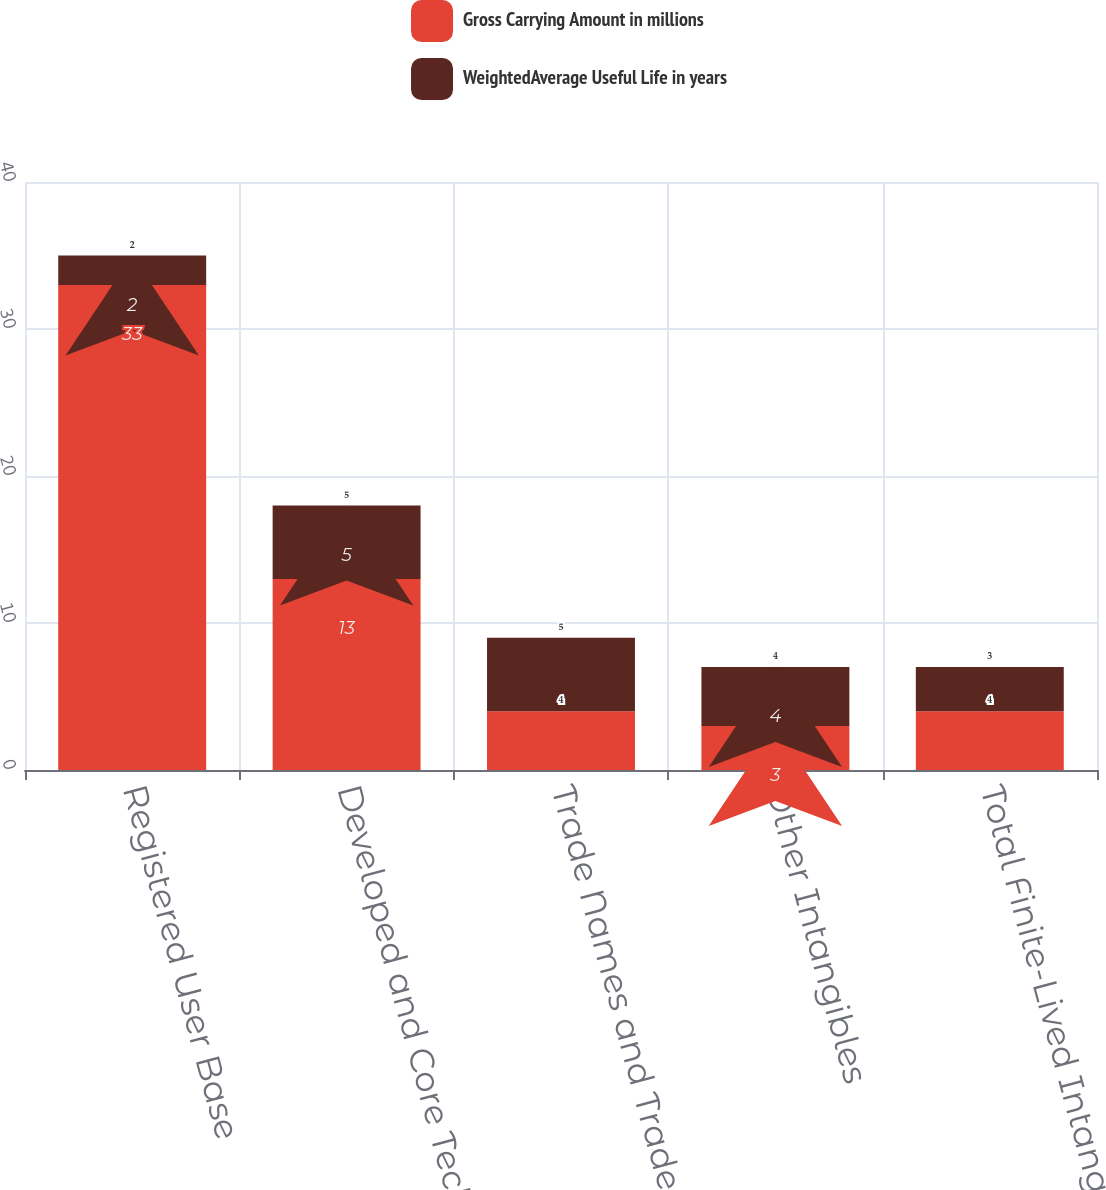Convert chart. <chart><loc_0><loc_0><loc_500><loc_500><stacked_bar_chart><ecel><fcel>Registered User Base<fcel>Developed and Core Technology<fcel>Trade Names and Trademarks<fcel>Other Intangibles<fcel>Total Finite-Lived Intangibles<nl><fcel>Gross Carrying Amount in millions<fcel>33<fcel>13<fcel>4<fcel>3<fcel>4<nl><fcel>WeightedAverage Useful Life in years<fcel>2<fcel>5<fcel>5<fcel>4<fcel>3<nl></chart> 